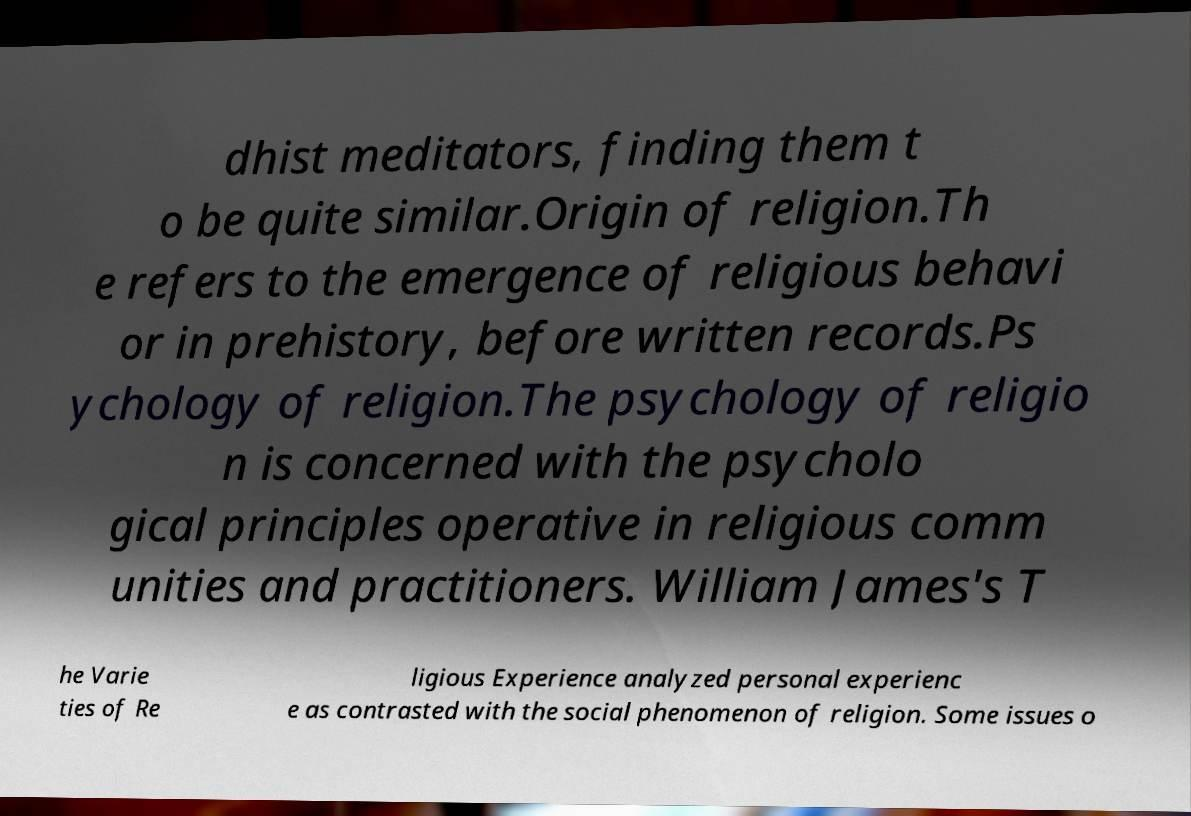For documentation purposes, I need the text within this image transcribed. Could you provide that? dhist meditators, finding them t o be quite similar.Origin of religion.Th e refers to the emergence of religious behavi or in prehistory, before written records.Ps ychology of religion.The psychology of religio n is concerned with the psycholo gical principles operative in religious comm unities and practitioners. William James's T he Varie ties of Re ligious Experience analyzed personal experienc e as contrasted with the social phenomenon of religion. Some issues o 